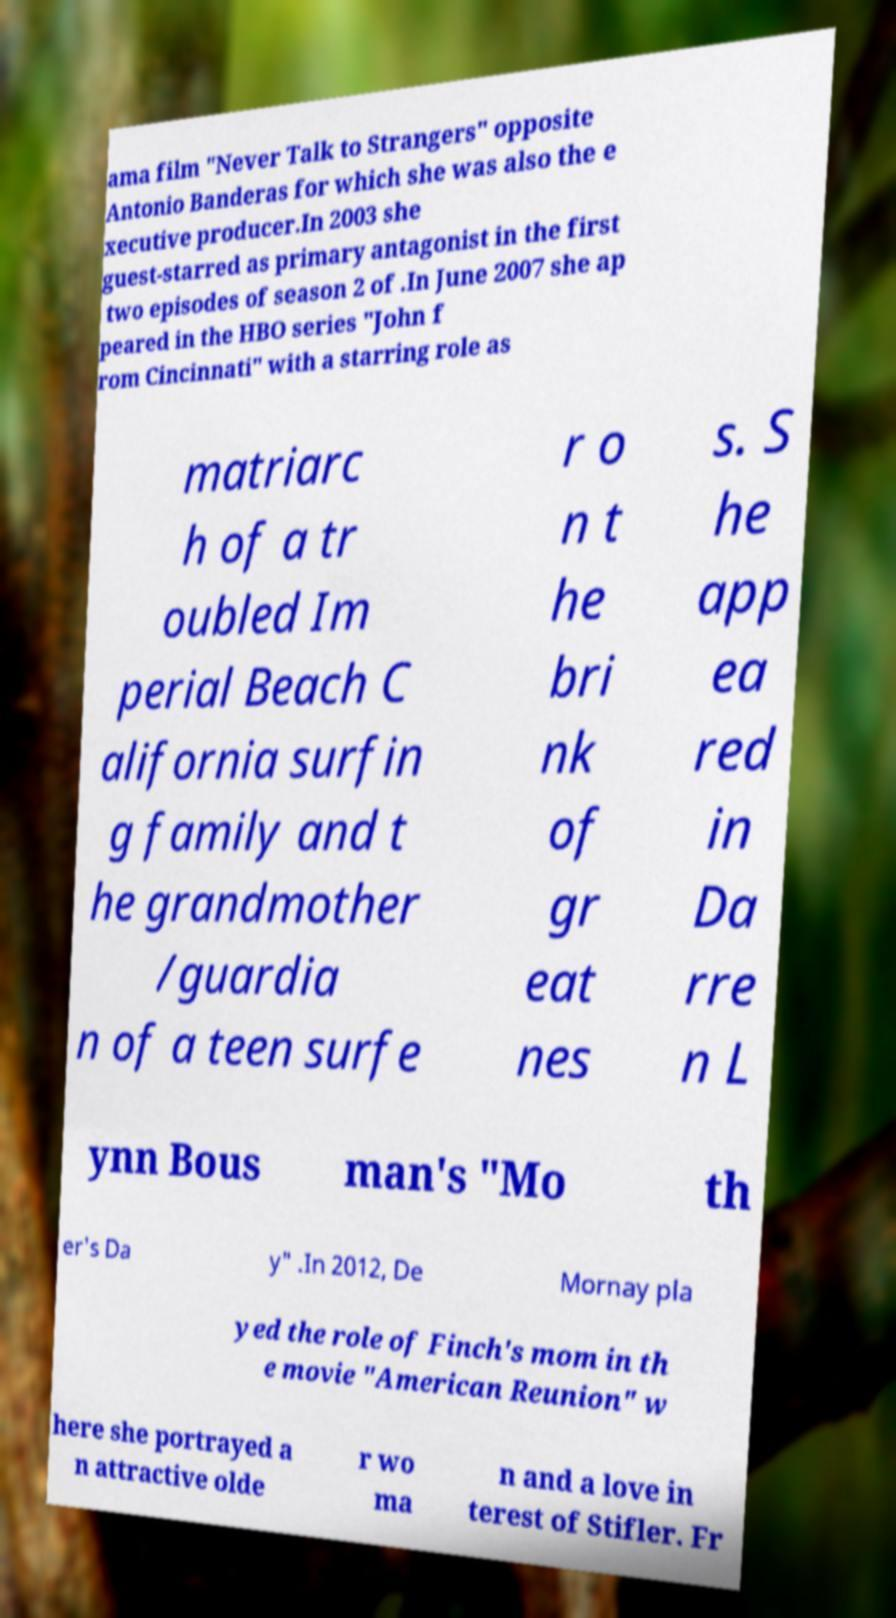Can you accurately transcribe the text from the provided image for me? ama film "Never Talk to Strangers" opposite Antonio Banderas for which she was also the e xecutive producer.In 2003 she guest-starred as primary antagonist in the first two episodes of season 2 of .In June 2007 she ap peared in the HBO series "John f rom Cincinnati" with a starring role as matriarc h of a tr oubled Im perial Beach C alifornia surfin g family and t he grandmother /guardia n of a teen surfe r o n t he bri nk of gr eat nes s. S he app ea red in Da rre n L ynn Bous man's "Mo th er's Da y" .In 2012, De Mornay pla yed the role of Finch's mom in th e movie "American Reunion" w here she portrayed a n attractive olde r wo ma n and a love in terest of Stifler. Fr 